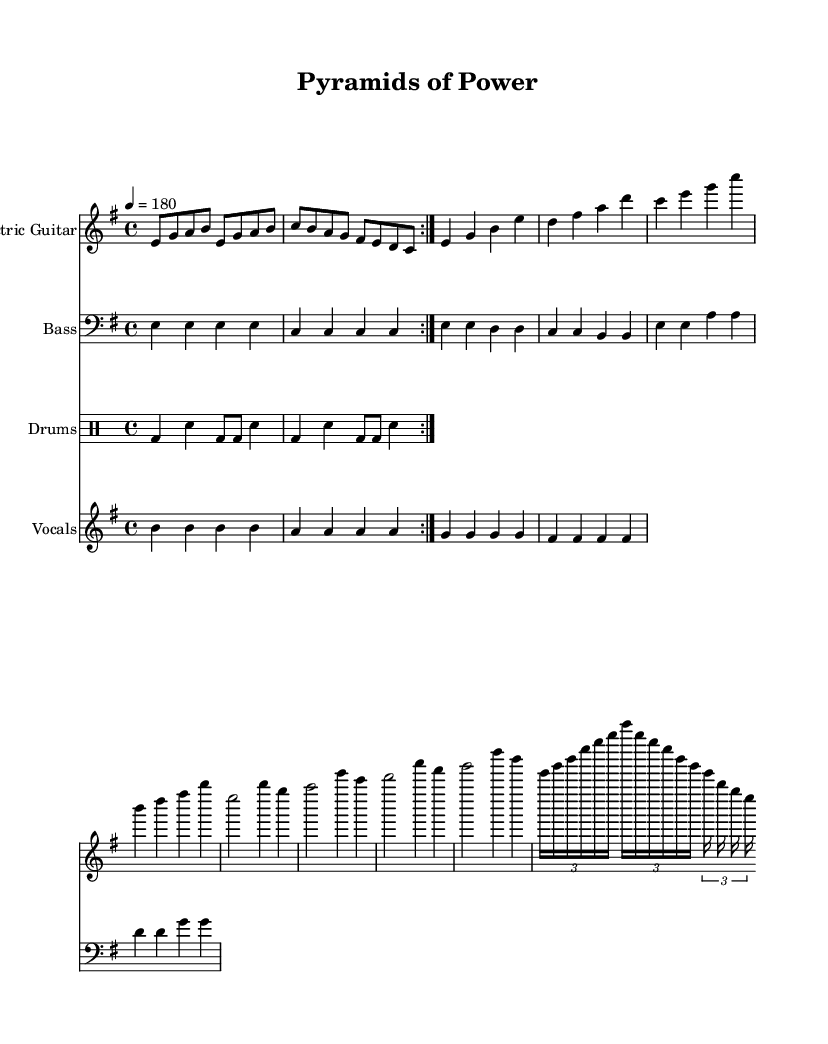What is the key signature of this music? The key signature is represented in the music as E minor, which is identifiable with one sharp (F#). This is determined by looking at the initial setup in the global variable, where the key is specified.
Answer: E minor What is the time signature of this music? The time signature indicated in the global variable is 4/4, which means there are four beats in each measure, and the quarter note gets one beat. This is a standard time signature commonly found in many genres, including Metal.
Answer: 4/4 What is the tempo of this piece? The tempo marking in the global variable specifies the speed of the music, set to 180 beats per minute. This is typically notated with a numerical tempo marking, providing a clear indication of how fast the music should be played.
Answer: 180 How many measures are in the main riff section? The main riff is shown in the electric guitar section and consists of four measures repeated twice, making a total of eight measures for this section. This can be confirmed by counting the bar lines in the specified music, noting the iteration of the section.
Answer: 8 What instrument is primarily playing the melody? The melody is primarily presented by the electric guitar, which is indicated at the start of its staff section. The notation shown therein clearly outlines the notes and rhythmic values that constitute the main musical ideas for this instrument.
Answer: Electric Guitar What type of beat does the drum part use? The drum part uses a basic rock beat which is characterized by bass drums (bd) and snare (sn) hits, identifiable by the pattern and distribution of the notes over the measures. This establishes the foundation typical in Metal music styles, following a straightforward rhythm.
Answer: Basic rock beat What is the thematic focus of the lyrics? The lyrics in this piece focus on ancient civilization imagery, particularly the mention of "ancient stones rise to the sky" and "pyramids of power." Lyrics are often crafted to evoke certain themes, and in this case, they reflect the grandeur and significance of historical landmarks.
Answer: Ancient civilizations 